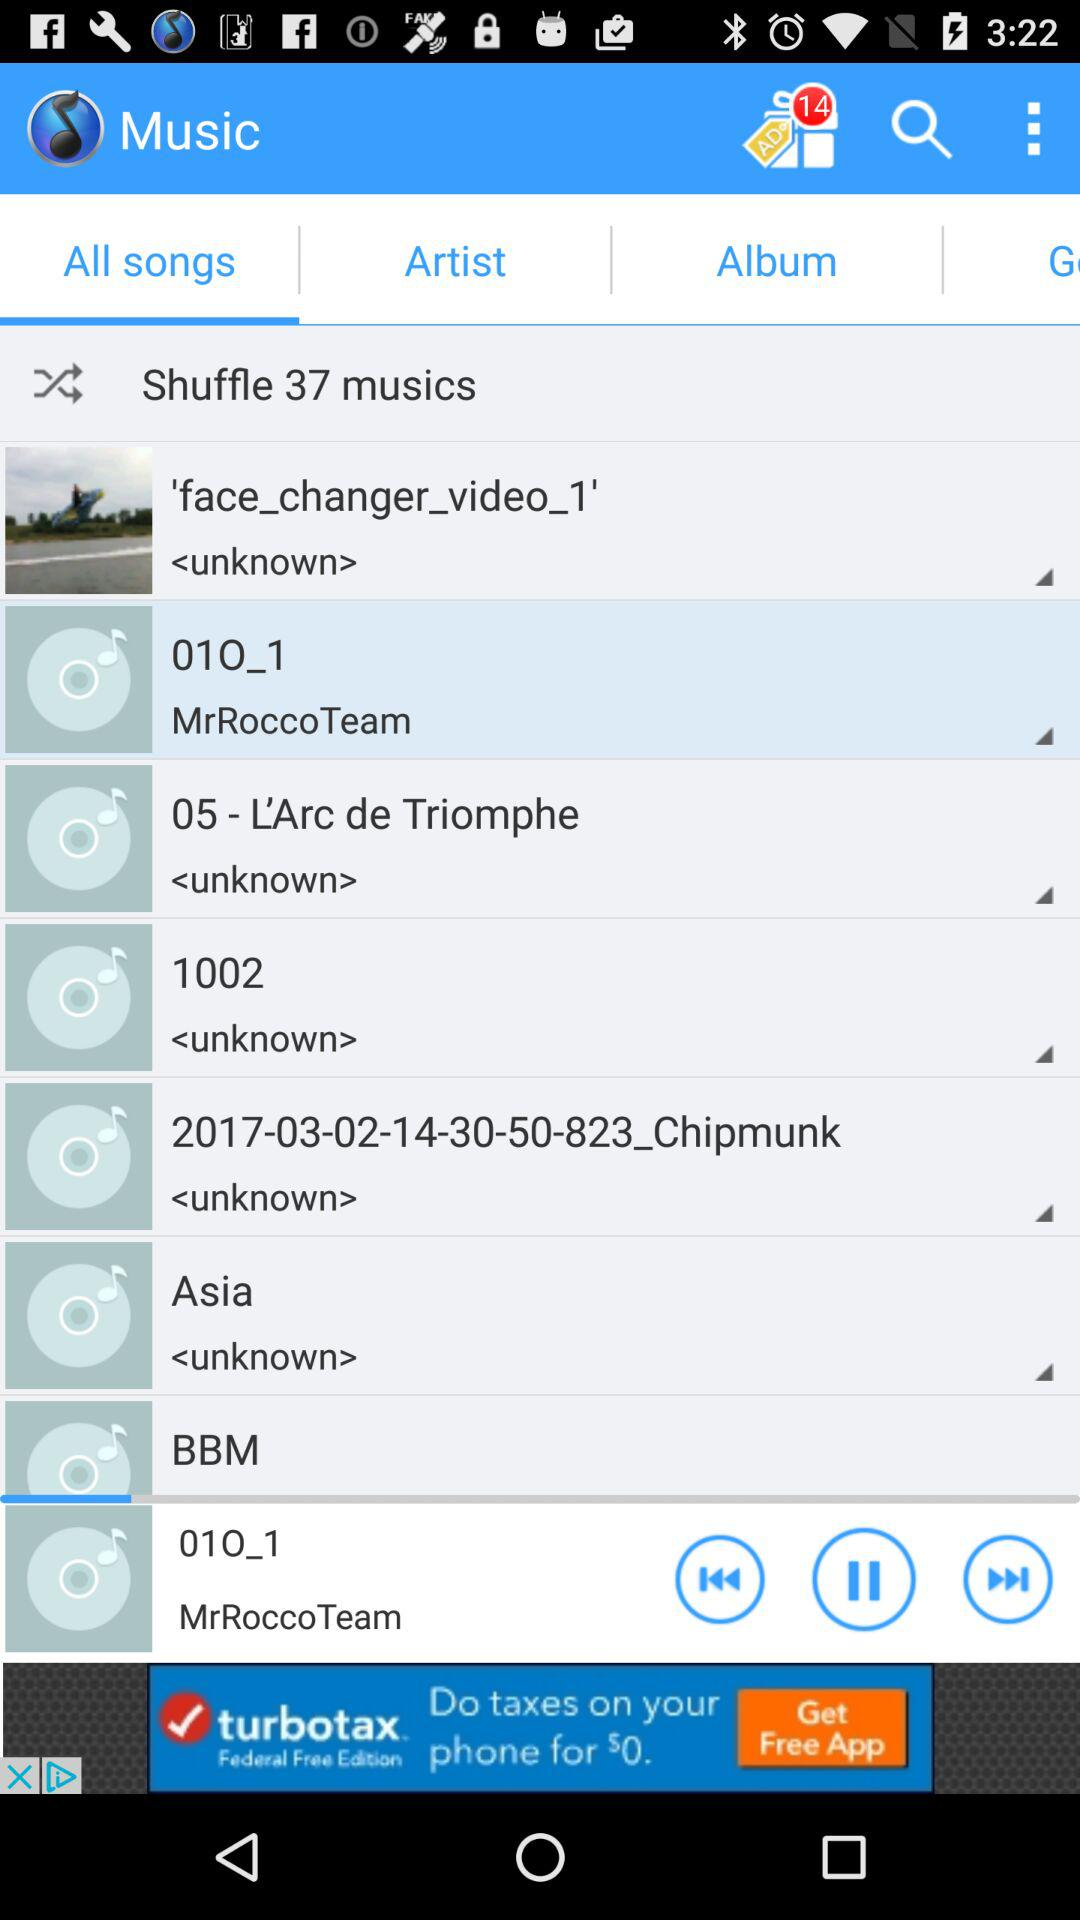What is the name of the application? The name of the application is "Music". 